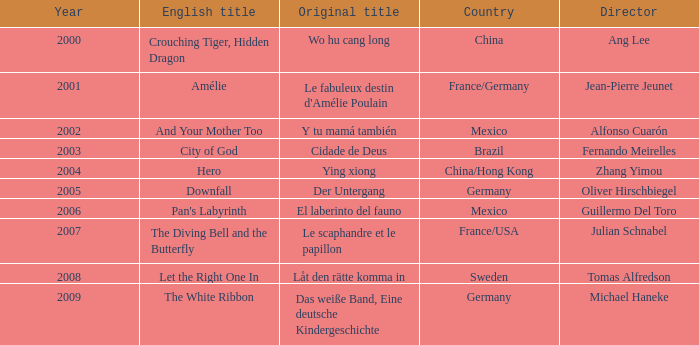Specify the title connected to jean-pierre jeunet. Amélie. 